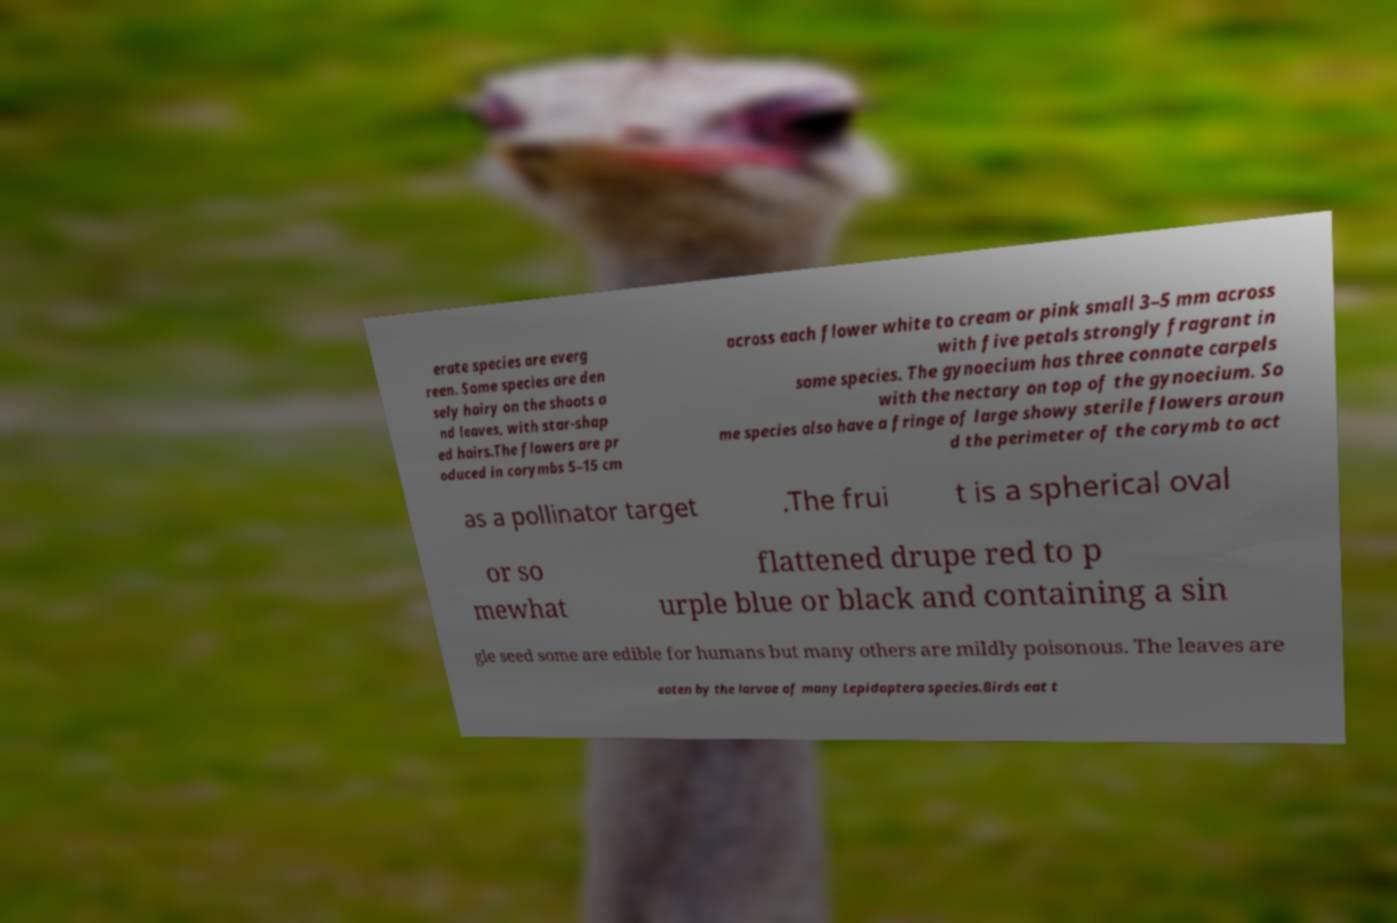Can you read and provide the text displayed in the image?This photo seems to have some interesting text. Can you extract and type it out for me? erate species are everg reen. Some species are den sely hairy on the shoots a nd leaves, with star-shap ed hairs.The flowers are pr oduced in corymbs 5–15 cm across each flower white to cream or pink small 3–5 mm across with five petals strongly fragrant in some species. The gynoecium has three connate carpels with the nectary on top of the gynoecium. So me species also have a fringe of large showy sterile flowers aroun d the perimeter of the corymb to act as a pollinator target .The frui t is a spherical oval or so mewhat flattened drupe red to p urple blue or black and containing a sin gle seed some are edible for humans but many others are mildly poisonous. The leaves are eaten by the larvae of many Lepidoptera species.Birds eat t 